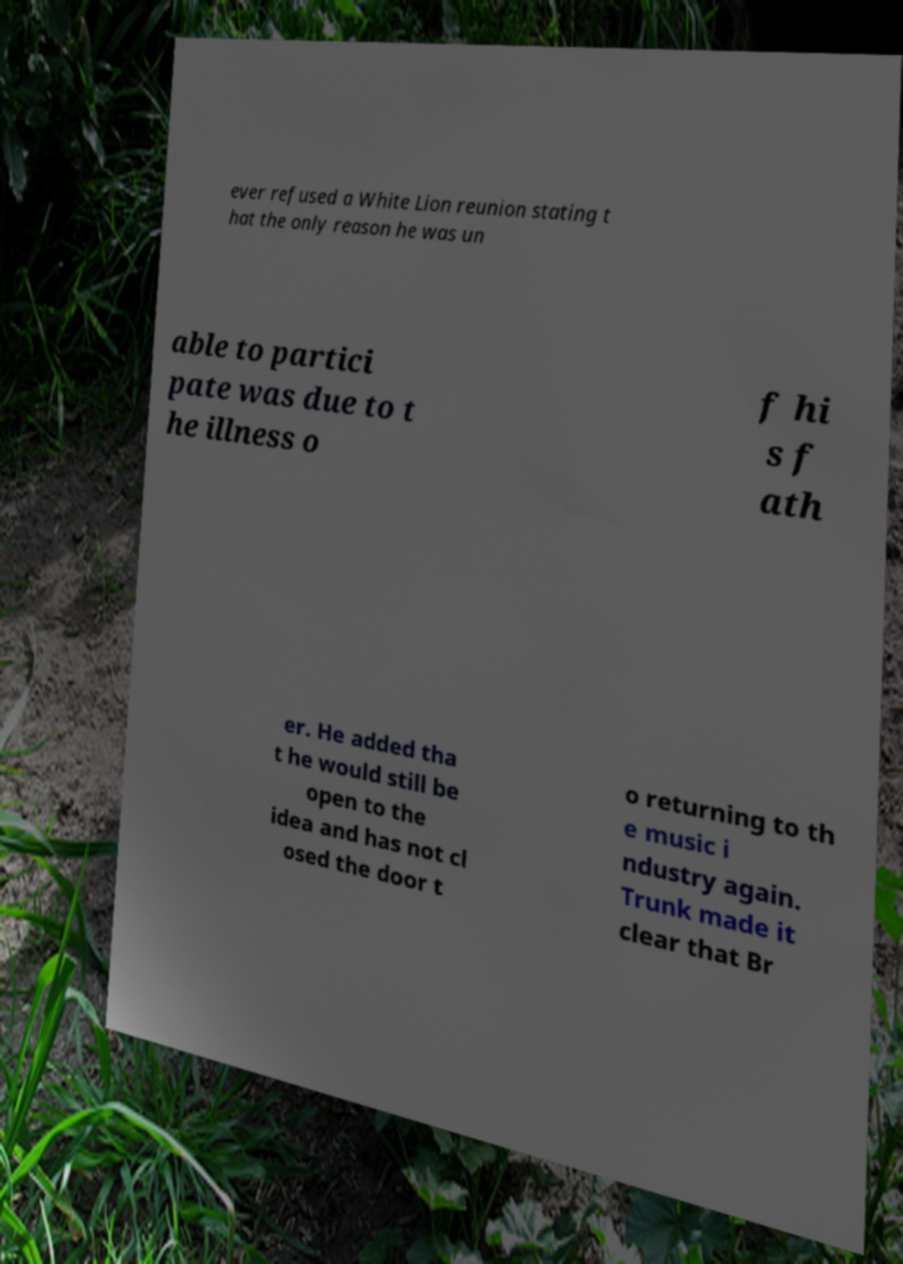There's text embedded in this image that I need extracted. Can you transcribe it verbatim? ever refused a White Lion reunion stating t hat the only reason he was un able to partici pate was due to t he illness o f hi s f ath er. He added tha t he would still be open to the idea and has not cl osed the door t o returning to th e music i ndustry again. Trunk made it clear that Br 